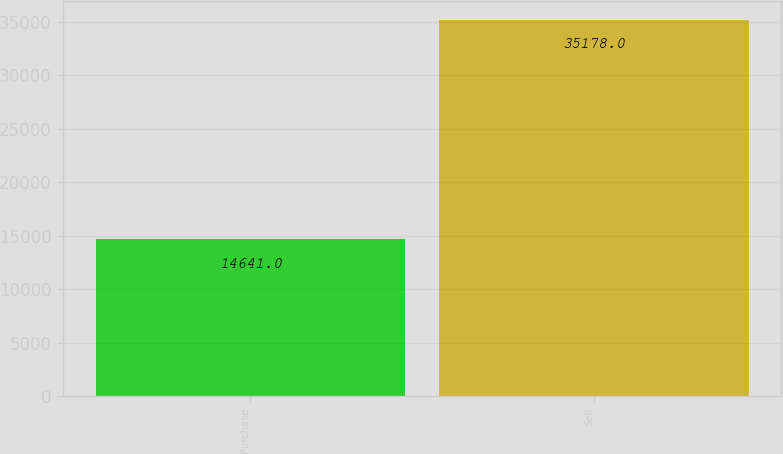Convert chart. <chart><loc_0><loc_0><loc_500><loc_500><bar_chart><fcel>Purchase<fcel>Sell<nl><fcel>14641<fcel>35178<nl></chart> 